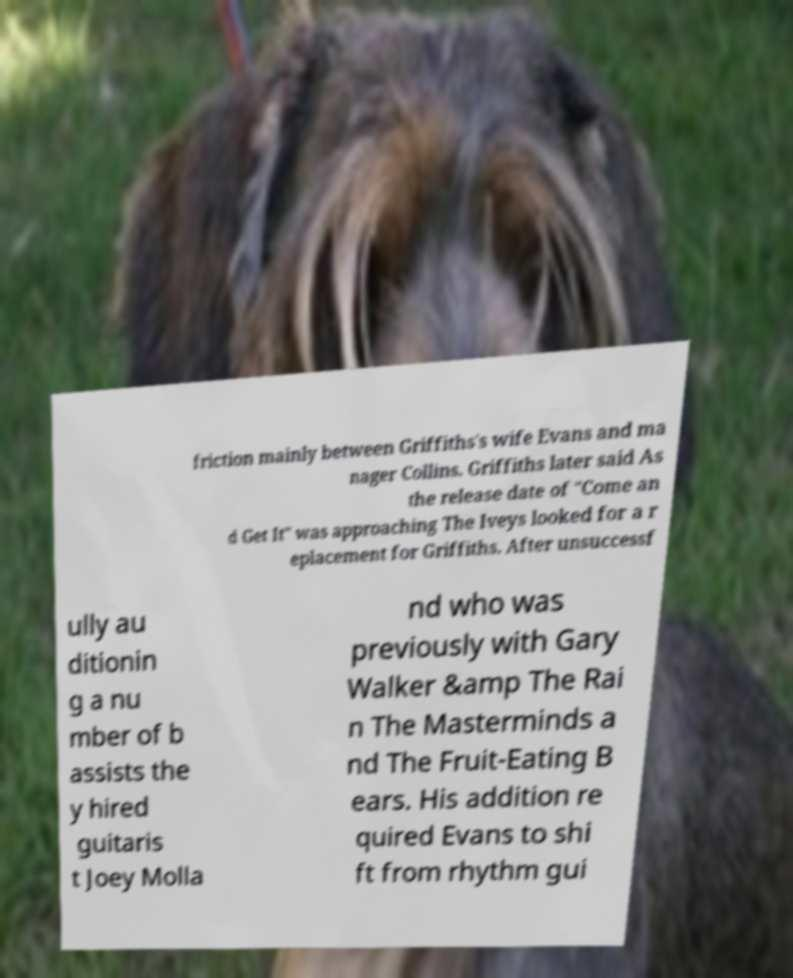I need the written content from this picture converted into text. Can you do that? friction mainly between Griffiths's wife Evans and ma nager Collins. Griffiths later said As the release date of "Come an d Get It" was approaching The Iveys looked for a r eplacement for Griffiths. After unsuccessf ully au ditionin g a nu mber of b assists the y hired guitaris t Joey Molla nd who was previously with Gary Walker &amp The Rai n The Masterminds a nd The Fruit-Eating B ears. His addition re quired Evans to shi ft from rhythm gui 